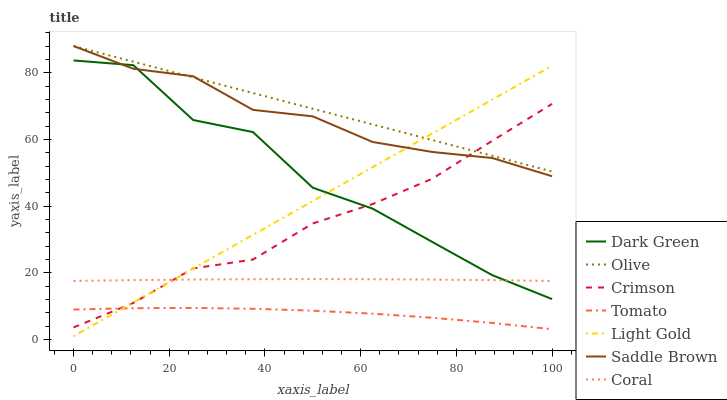Does Tomato have the minimum area under the curve?
Answer yes or no. Yes. Does Olive have the maximum area under the curve?
Answer yes or no. Yes. Does Coral have the minimum area under the curve?
Answer yes or no. No. Does Coral have the maximum area under the curve?
Answer yes or no. No. Is Light Gold the smoothest?
Answer yes or no. Yes. Is Dark Green the roughest?
Answer yes or no. Yes. Is Coral the smoothest?
Answer yes or no. No. Is Coral the roughest?
Answer yes or no. No. Does Light Gold have the lowest value?
Answer yes or no. Yes. Does Coral have the lowest value?
Answer yes or no. No. Does Saddle Brown have the highest value?
Answer yes or no. Yes. Does Coral have the highest value?
Answer yes or no. No. Is Tomato less than Dark Green?
Answer yes or no. Yes. Is Saddle Brown greater than Coral?
Answer yes or no. Yes. Does Olive intersect Saddle Brown?
Answer yes or no. Yes. Is Olive less than Saddle Brown?
Answer yes or no. No. Is Olive greater than Saddle Brown?
Answer yes or no. No. Does Tomato intersect Dark Green?
Answer yes or no. No. 